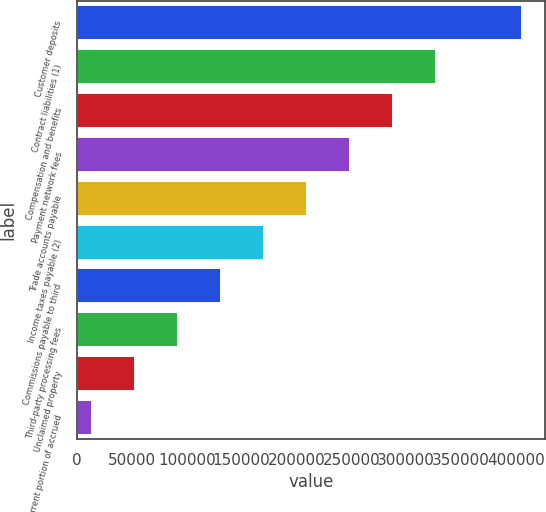<chart> <loc_0><loc_0><loc_500><loc_500><bar_chart><fcel>Customer deposits<fcel>Contract liabilities (1)<fcel>Compensation and benefits<fcel>Payment network fees<fcel>Trade accounts payable<fcel>Income taxes payable (2)<fcel>Commissions payable to third<fcel>Third-party processing fees<fcel>Unclaimed property<fcel>Current portion of accrued<nl><fcel>406117<fcel>327696<fcel>288485<fcel>249275<fcel>210064<fcel>170853<fcel>131643<fcel>92432.2<fcel>53221.6<fcel>14011<nl></chart> 